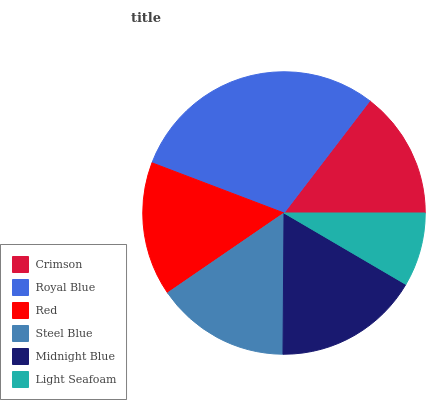Is Light Seafoam the minimum?
Answer yes or no. Yes. Is Royal Blue the maximum?
Answer yes or no. Yes. Is Red the minimum?
Answer yes or no. No. Is Red the maximum?
Answer yes or no. No. Is Royal Blue greater than Red?
Answer yes or no. Yes. Is Red less than Royal Blue?
Answer yes or no. Yes. Is Red greater than Royal Blue?
Answer yes or no. No. Is Royal Blue less than Red?
Answer yes or no. No. Is Red the high median?
Answer yes or no. Yes. Is Steel Blue the low median?
Answer yes or no. Yes. Is Steel Blue the high median?
Answer yes or no. No. Is Midnight Blue the low median?
Answer yes or no. No. 